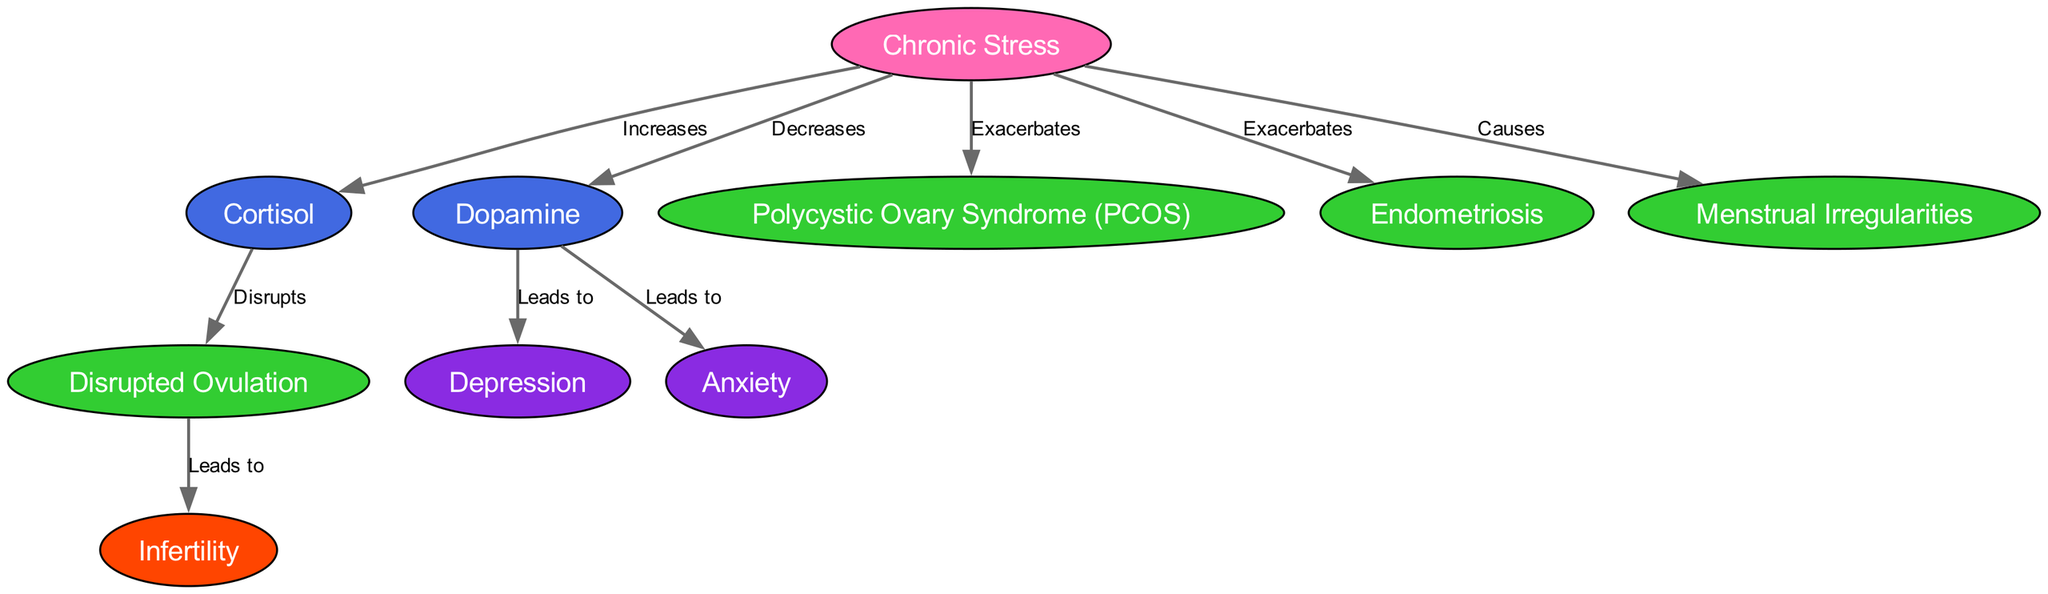What is the total number of nodes in the diagram? The diagram includes a total of 10 nodes, which are elements such as Chronic Stress, Cortisol, Dopamine, and others related to female reproductive health.
Answer: 10 Which hormone is increased by chronic stress? The diagram indicates that chronic stress increases the hormone Cortisol, as shown by the directed edge from the stress node to the cortisol node.
Answer: Cortisol What is the relationship between dopamine and anxiety? The diagram shows a direct connection where dopamine leads to anxiety, indicating that a decrease in dopamine contributes to increased anxiety levels.
Answer: Leads to How many outcomes are displayed in the diagram? Upon examining the nodes, there is 1 outcome highlighted in the diagram, which is Infertility, resulting from disrupted ovulation.
Answer: 1 What condition is exacerbated by chronic stress? The diagram clearly states that chronic stress exacerbates both Polycystic Ovary Syndrome (PCOS) and Endometriosis, as reflected by the connection from the stress node to these condition nodes.
Answer: Polycystic Ovary Syndrome (PCOS) and Endometriosis What condition leads to infertility? According to the diagram, the condition that leads to infertility is Disrupted Ovulation, as indicated by the relationship between the ovulation node and the infertility node.
Answer: Disrupted Ovulation What are the effects of dopamine mentioned in the diagram? The diagram indicates that a decrease in dopamine leads to two effects: Depression and Anxiety, as seen in the connections from dopamine to these effect nodes.
Answer: Depression and Anxiety Which condition is caused directly by chronic stress? The diagram specifies that chronic stress causes Menstrual Irregularities, establishing a direct link from the stress node to the menstrual irregularities node.
Answer: Menstrual Irregularities What hormone is decreased due to chronic stress? The diagram identifies that chronic stress decreases the hormone Dopamine, as indicated by the directed edge from the stress node to the dopamine node.
Answer: Dopamine 